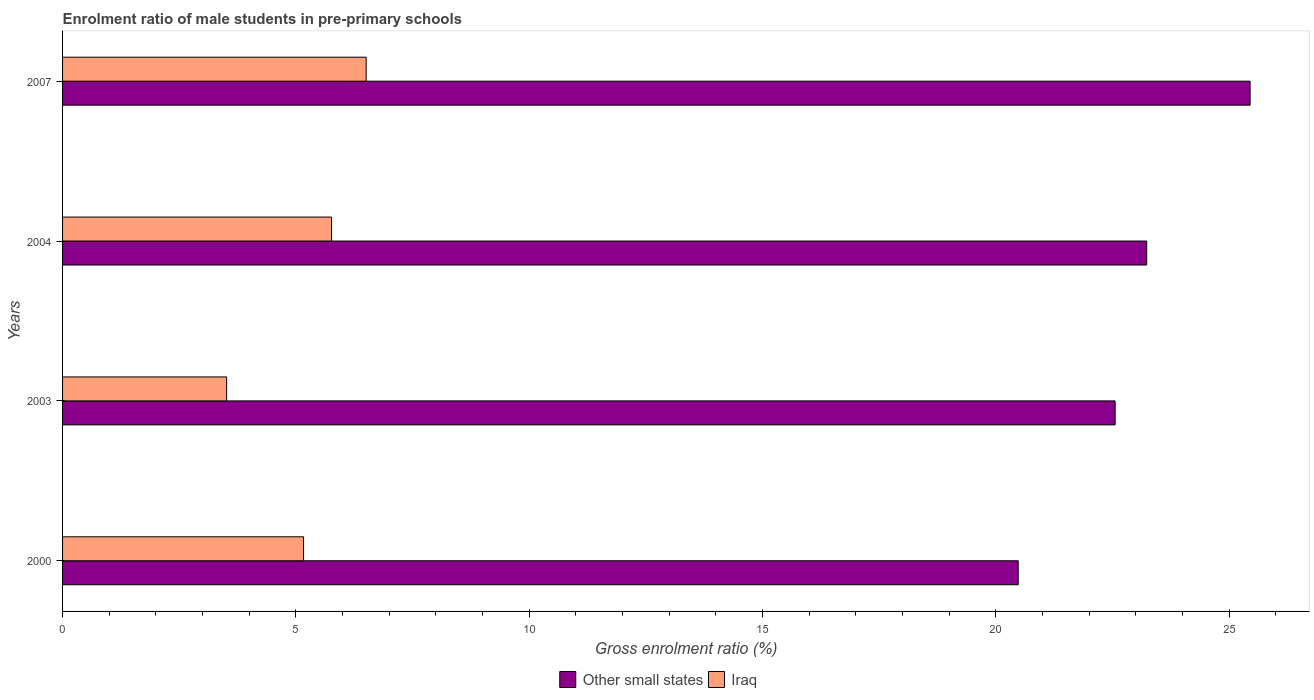How many different coloured bars are there?
Your response must be concise. 2. How many groups of bars are there?
Keep it short and to the point. 4. Are the number of bars per tick equal to the number of legend labels?
Provide a short and direct response. Yes. In how many cases, is the number of bars for a given year not equal to the number of legend labels?
Provide a short and direct response. 0. What is the enrolment ratio of male students in pre-primary schools in Other small states in 2007?
Ensure brevity in your answer.  25.45. Across all years, what is the maximum enrolment ratio of male students in pre-primary schools in Iraq?
Your answer should be very brief. 6.51. Across all years, what is the minimum enrolment ratio of male students in pre-primary schools in Iraq?
Offer a very short reply. 3.52. In which year was the enrolment ratio of male students in pre-primary schools in Iraq maximum?
Offer a terse response. 2007. In which year was the enrolment ratio of male students in pre-primary schools in Other small states minimum?
Your answer should be compact. 2000. What is the total enrolment ratio of male students in pre-primary schools in Other small states in the graph?
Your response must be concise. 91.71. What is the difference between the enrolment ratio of male students in pre-primary schools in Other small states in 2000 and that in 2004?
Your response must be concise. -2.75. What is the difference between the enrolment ratio of male students in pre-primary schools in Other small states in 2004 and the enrolment ratio of male students in pre-primary schools in Iraq in 2000?
Your answer should be compact. 18.07. What is the average enrolment ratio of male students in pre-primary schools in Other small states per year?
Provide a short and direct response. 22.93. In the year 2004, what is the difference between the enrolment ratio of male students in pre-primary schools in Iraq and enrolment ratio of male students in pre-primary schools in Other small states?
Provide a succinct answer. -17.47. In how many years, is the enrolment ratio of male students in pre-primary schools in Other small states greater than 18 %?
Give a very brief answer. 4. What is the ratio of the enrolment ratio of male students in pre-primary schools in Iraq in 2000 to that in 2003?
Keep it short and to the point. 1.47. Is the enrolment ratio of male students in pre-primary schools in Other small states in 2003 less than that in 2007?
Provide a short and direct response. Yes. What is the difference between the highest and the second highest enrolment ratio of male students in pre-primary schools in Other small states?
Provide a succinct answer. 2.22. What is the difference between the highest and the lowest enrolment ratio of male students in pre-primary schools in Other small states?
Your answer should be very brief. 4.97. Is the sum of the enrolment ratio of male students in pre-primary schools in Other small states in 2000 and 2003 greater than the maximum enrolment ratio of male students in pre-primary schools in Iraq across all years?
Make the answer very short. Yes. What does the 1st bar from the top in 2004 represents?
Your answer should be very brief. Iraq. What does the 2nd bar from the bottom in 2000 represents?
Your response must be concise. Iraq. Are all the bars in the graph horizontal?
Your answer should be compact. Yes. How many years are there in the graph?
Your answer should be very brief. 4. What is the difference between two consecutive major ticks on the X-axis?
Give a very brief answer. 5. Are the values on the major ticks of X-axis written in scientific E-notation?
Your response must be concise. No. Does the graph contain any zero values?
Provide a short and direct response. No. Does the graph contain grids?
Make the answer very short. No. Where does the legend appear in the graph?
Your answer should be compact. Bottom center. How are the legend labels stacked?
Your answer should be compact. Horizontal. What is the title of the graph?
Your response must be concise. Enrolment ratio of male students in pre-primary schools. What is the Gross enrolment ratio (%) of Other small states in 2000?
Keep it short and to the point. 20.48. What is the Gross enrolment ratio (%) of Iraq in 2000?
Offer a terse response. 5.16. What is the Gross enrolment ratio (%) in Other small states in 2003?
Give a very brief answer. 22.55. What is the Gross enrolment ratio (%) of Iraq in 2003?
Offer a terse response. 3.52. What is the Gross enrolment ratio (%) in Other small states in 2004?
Your answer should be very brief. 23.23. What is the Gross enrolment ratio (%) in Iraq in 2004?
Your answer should be very brief. 5.76. What is the Gross enrolment ratio (%) in Other small states in 2007?
Make the answer very short. 25.45. What is the Gross enrolment ratio (%) of Iraq in 2007?
Make the answer very short. 6.51. Across all years, what is the maximum Gross enrolment ratio (%) of Other small states?
Your answer should be very brief. 25.45. Across all years, what is the maximum Gross enrolment ratio (%) in Iraq?
Your answer should be very brief. 6.51. Across all years, what is the minimum Gross enrolment ratio (%) in Other small states?
Make the answer very short. 20.48. Across all years, what is the minimum Gross enrolment ratio (%) of Iraq?
Your answer should be compact. 3.52. What is the total Gross enrolment ratio (%) in Other small states in the graph?
Your response must be concise. 91.71. What is the total Gross enrolment ratio (%) in Iraq in the graph?
Offer a very short reply. 20.95. What is the difference between the Gross enrolment ratio (%) of Other small states in 2000 and that in 2003?
Ensure brevity in your answer.  -2.08. What is the difference between the Gross enrolment ratio (%) of Iraq in 2000 and that in 2003?
Provide a succinct answer. 1.65. What is the difference between the Gross enrolment ratio (%) in Other small states in 2000 and that in 2004?
Provide a succinct answer. -2.75. What is the difference between the Gross enrolment ratio (%) of Iraq in 2000 and that in 2004?
Offer a terse response. -0.6. What is the difference between the Gross enrolment ratio (%) in Other small states in 2000 and that in 2007?
Provide a short and direct response. -4.97. What is the difference between the Gross enrolment ratio (%) in Iraq in 2000 and that in 2007?
Your answer should be compact. -1.34. What is the difference between the Gross enrolment ratio (%) of Other small states in 2003 and that in 2004?
Provide a succinct answer. -0.68. What is the difference between the Gross enrolment ratio (%) in Iraq in 2003 and that in 2004?
Make the answer very short. -2.25. What is the difference between the Gross enrolment ratio (%) of Other small states in 2003 and that in 2007?
Provide a succinct answer. -2.89. What is the difference between the Gross enrolment ratio (%) in Iraq in 2003 and that in 2007?
Give a very brief answer. -2.99. What is the difference between the Gross enrolment ratio (%) in Other small states in 2004 and that in 2007?
Provide a short and direct response. -2.22. What is the difference between the Gross enrolment ratio (%) in Iraq in 2004 and that in 2007?
Offer a very short reply. -0.74. What is the difference between the Gross enrolment ratio (%) in Other small states in 2000 and the Gross enrolment ratio (%) in Iraq in 2003?
Your answer should be compact. 16.96. What is the difference between the Gross enrolment ratio (%) in Other small states in 2000 and the Gross enrolment ratio (%) in Iraq in 2004?
Provide a succinct answer. 14.71. What is the difference between the Gross enrolment ratio (%) of Other small states in 2000 and the Gross enrolment ratio (%) of Iraq in 2007?
Ensure brevity in your answer.  13.97. What is the difference between the Gross enrolment ratio (%) in Other small states in 2003 and the Gross enrolment ratio (%) in Iraq in 2004?
Your answer should be very brief. 16.79. What is the difference between the Gross enrolment ratio (%) of Other small states in 2003 and the Gross enrolment ratio (%) of Iraq in 2007?
Keep it short and to the point. 16.05. What is the difference between the Gross enrolment ratio (%) of Other small states in 2004 and the Gross enrolment ratio (%) of Iraq in 2007?
Make the answer very short. 16.73. What is the average Gross enrolment ratio (%) of Other small states per year?
Keep it short and to the point. 22.93. What is the average Gross enrolment ratio (%) of Iraq per year?
Your answer should be very brief. 5.24. In the year 2000, what is the difference between the Gross enrolment ratio (%) in Other small states and Gross enrolment ratio (%) in Iraq?
Provide a succinct answer. 15.31. In the year 2003, what is the difference between the Gross enrolment ratio (%) of Other small states and Gross enrolment ratio (%) of Iraq?
Keep it short and to the point. 19.04. In the year 2004, what is the difference between the Gross enrolment ratio (%) in Other small states and Gross enrolment ratio (%) in Iraq?
Your answer should be very brief. 17.47. In the year 2007, what is the difference between the Gross enrolment ratio (%) in Other small states and Gross enrolment ratio (%) in Iraq?
Your response must be concise. 18.94. What is the ratio of the Gross enrolment ratio (%) in Other small states in 2000 to that in 2003?
Make the answer very short. 0.91. What is the ratio of the Gross enrolment ratio (%) of Iraq in 2000 to that in 2003?
Offer a very short reply. 1.47. What is the ratio of the Gross enrolment ratio (%) of Other small states in 2000 to that in 2004?
Offer a very short reply. 0.88. What is the ratio of the Gross enrolment ratio (%) in Iraq in 2000 to that in 2004?
Your answer should be very brief. 0.9. What is the ratio of the Gross enrolment ratio (%) of Other small states in 2000 to that in 2007?
Ensure brevity in your answer.  0.8. What is the ratio of the Gross enrolment ratio (%) in Iraq in 2000 to that in 2007?
Provide a succinct answer. 0.79. What is the ratio of the Gross enrolment ratio (%) of Other small states in 2003 to that in 2004?
Ensure brevity in your answer.  0.97. What is the ratio of the Gross enrolment ratio (%) of Iraq in 2003 to that in 2004?
Give a very brief answer. 0.61. What is the ratio of the Gross enrolment ratio (%) of Other small states in 2003 to that in 2007?
Offer a very short reply. 0.89. What is the ratio of the Gross enrolment ratio (%) of Iraq in 2003 to that in 2007?
Offer a very short reply. 0.54. What is the ratio of the Gross enrolment ratio (%) of Other small states in 2004 to that in 2007?
Offer a very short reply. 0.91. What is the ratio of the Gross enrolment ratio (%) in Iraq in 2004 to that in 2007?
Ensure brevity in your answer.  0.89. What is the difference between the highest and the second highest Gross enrolment ratio (%) in Other small states?
Ensure brevity in your answer.  2.22. What is the difference between the highest and the second highest Gross enrolment ratio (%) of Iraq?
Offer a very short reply. 0.74. What is the difference between the highest and the lowest Gross enrolment ratio (%) of Other small states?
Offer a terse response. 4.97. What is the difference between the highest and the lowest Gross enrolment ratio (%) in Iraq?
Give a very brief answer. 2.99. 